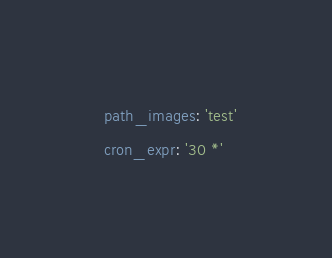Convert code to text. <code><loc_0><loc_0><loc_500><loc_500><_YAML_>  path_images: 'test'
  cron_expr: '30 *'</code> 